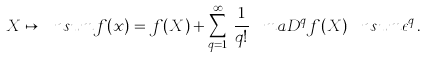<formula> <loc_0><loc_0><loc_500><loc_500>X \mapsto \ n s u m { f ( x ) } = f ( X ) + \sum _ { q = 1 } ^ { \infty } \, \frac { 1 } { q ! } \, \ m a { D } ^ { q } f ( X ) \, \ n s u m { \epsilon ^ { q } } \, .</formula> 